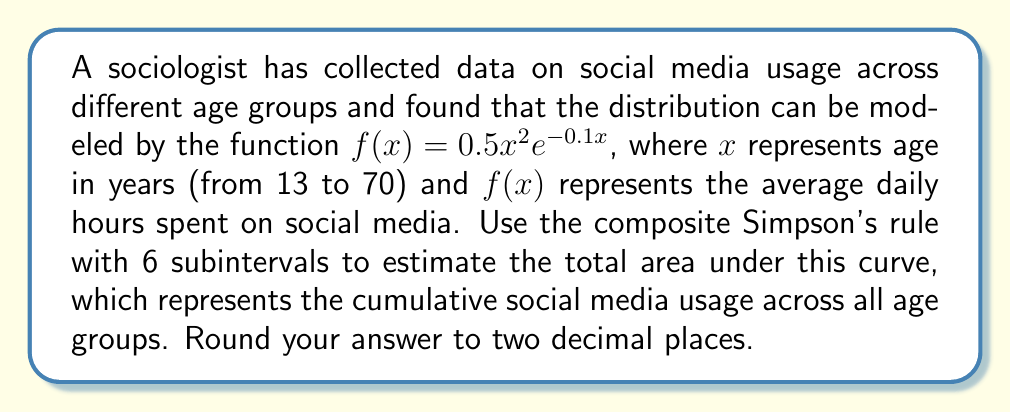Can you solve this math problem? To solve this problem, we'll use the composite Simpson's rule with 6 subintervals. The formula for the composite Simpson's rule is:

$$\int_a^b f(x)dx \approx \frac{h}{3}\left[f(x_0) + 4f(x_1) + 2f(x_2) + 4f(x_3) + 2f(x_4) + 4f(x_5) + f(x_6)\right]$$

where $h = \frac{b-a}{n}$, $n$ is the number of subintervals, and $x_i = a + ih$ for $i = 0, 1, ..., n$.

Given:
- $f(x) = 0.5x^2e^{-0.1x}$
- $a = 13$ (lower limit)
- $b = 70$ (upper limit)
- $n = 6$ (number of subintervals)

Step 1: Calculate $h$
$h = \frac{b-a}{n} = \frac{70-13}{6} = 9.5$

Step 2: Calculate $x_i$ values
$x_0 = 13$
$x_1 = 22.5$
$x_2 = 32$
$x_3 = 41.5$
$x_4 = 51$
$x_5 = 60.5$
$x_6 = 70$

Step 3: Calculate $f(x_i)$ values
$f(x_0) = 0.5(13^2)e^{-0.1(13)} = 37.30$
$f(x_1) = 0.5(22.5^2)e^{-0.1(22.5)} = 72.97$
$f(x_2) = 0.5(32^2)e^{-0.1(32)} = 90.51$
$f(x_3) = 0.5(41.5^2)e^{-0.1(41.5)} = 93.76$
$f(x_4) = 0.5(51^2)e^{-0.1(51)} = 86.62$
$f(x_5) = 0.5(60.5^2)e^{-0.1(60.5)} = 73.31$
$f(x_6) = 0.5(70^2)e^{-0.1(70)} = 58.40$

Step 4: Apply the composite Simpson's rule
$$\begin{aligned}
\int_{13}^{70} f(x)dx &\approx \frac{9.5}{3}[37.30 + 4(72.97) + 2(90.51) + 4(93.76) + 2(86.62) + 4(73.31) + 58.40] \\
&= 3.1667[37.30 + 291.88 + 181.02 + 375.04 + 173.24 + 293.24 + 58.40] \\
&= 3.1667 \times 1410.12 \\
&= 4465.85
\end{aligned}$$

Therefore, the estimated total area under the curve is approximately 4465.85 hour-years.
Answer: 4465.85 hour-years 